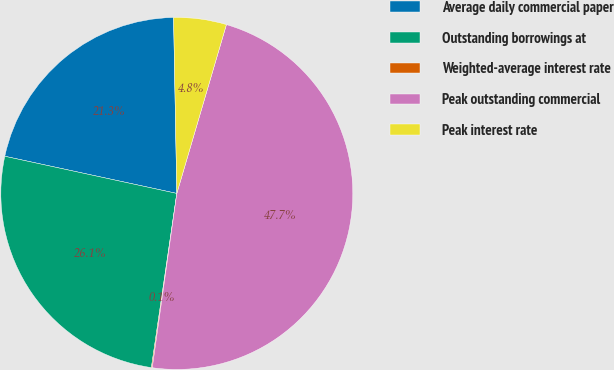<chart> <loc_0><loc_0><loc_500><loc_500><pie_chart><fcel>Average daily commercial paper<fcel>Outstanding borrowings at<fcel>Weighted-average interest rate<fcel>Peak outstanding commercial<fcel>Peak interest rate<nl><fcel>21.32%<fcel>26.08%<fcel>0.08%<fcel>47.68%<fcel>4.84%<nl></chart> 